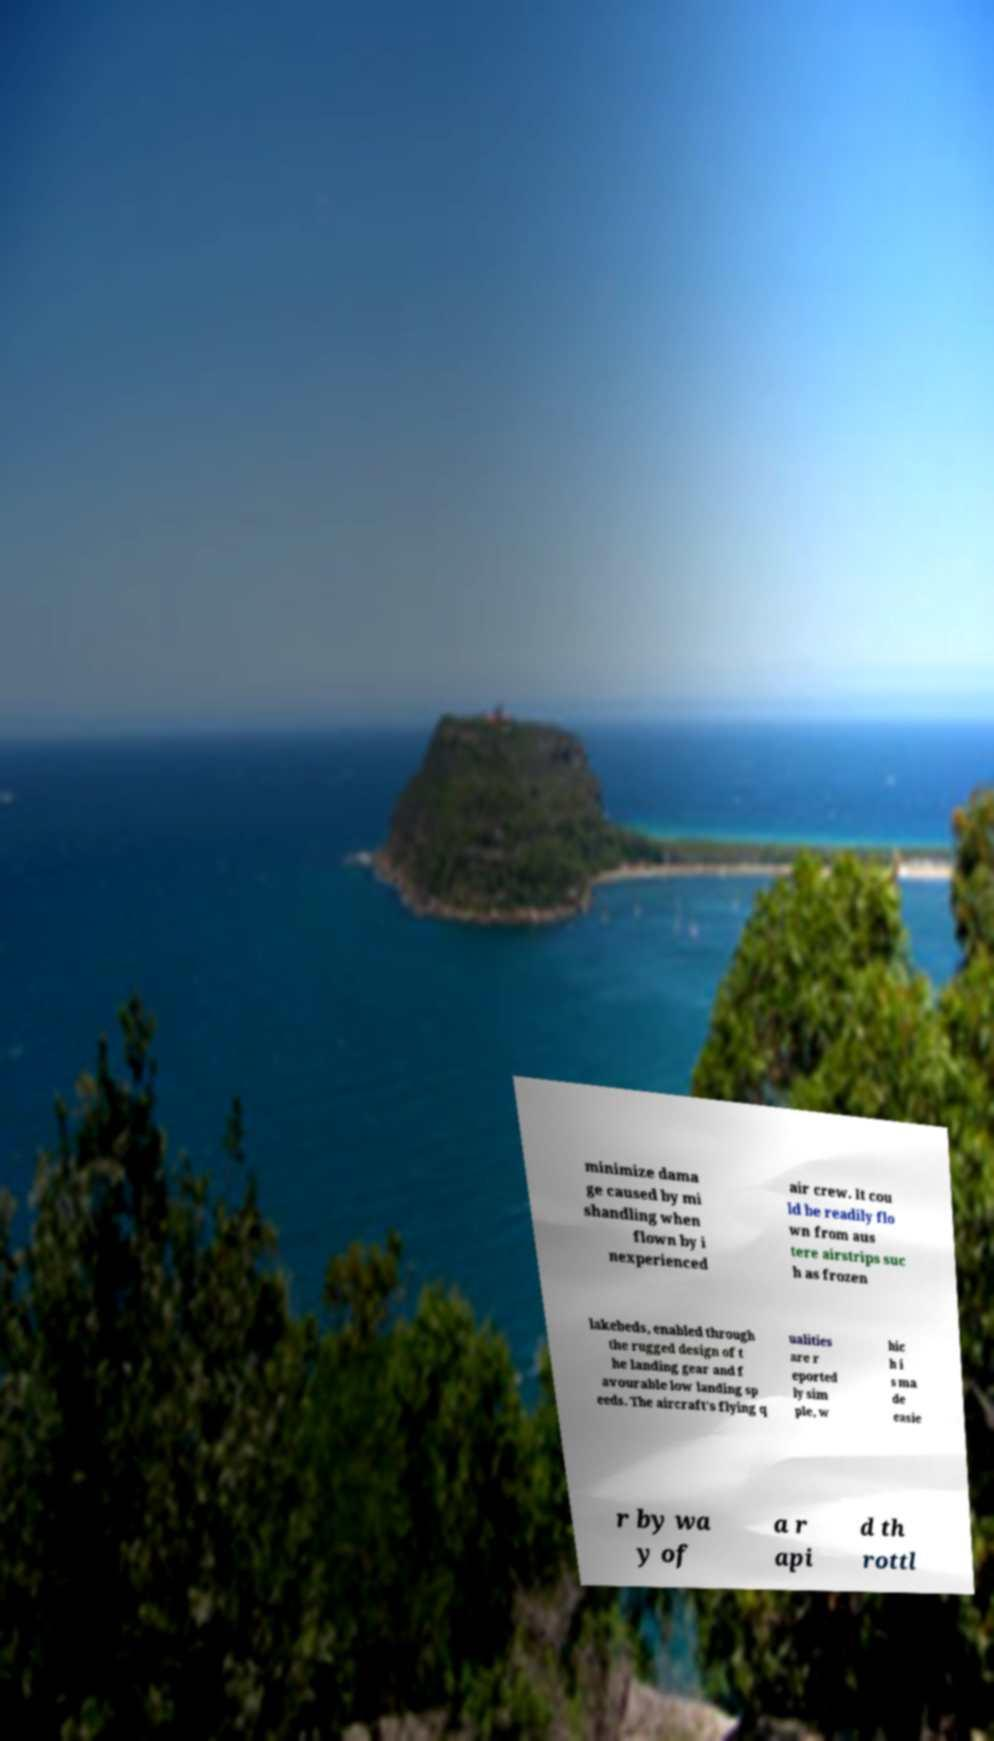I need the written content from this picture converted into text. Can you do that? minimize dama ge caused by mi shandling when flown by i nexperienced air crew. It cou ld be readily flo wn from aus tere airstrips suc h as frozen lakebeds, enabled through the rugged design of t he landing gear and f avourable low landing sp eeds. The aircraft's flying q ualities are r eported ly sim ple, w hic h i s ma de easie r by wa y of a r api d th rottl 